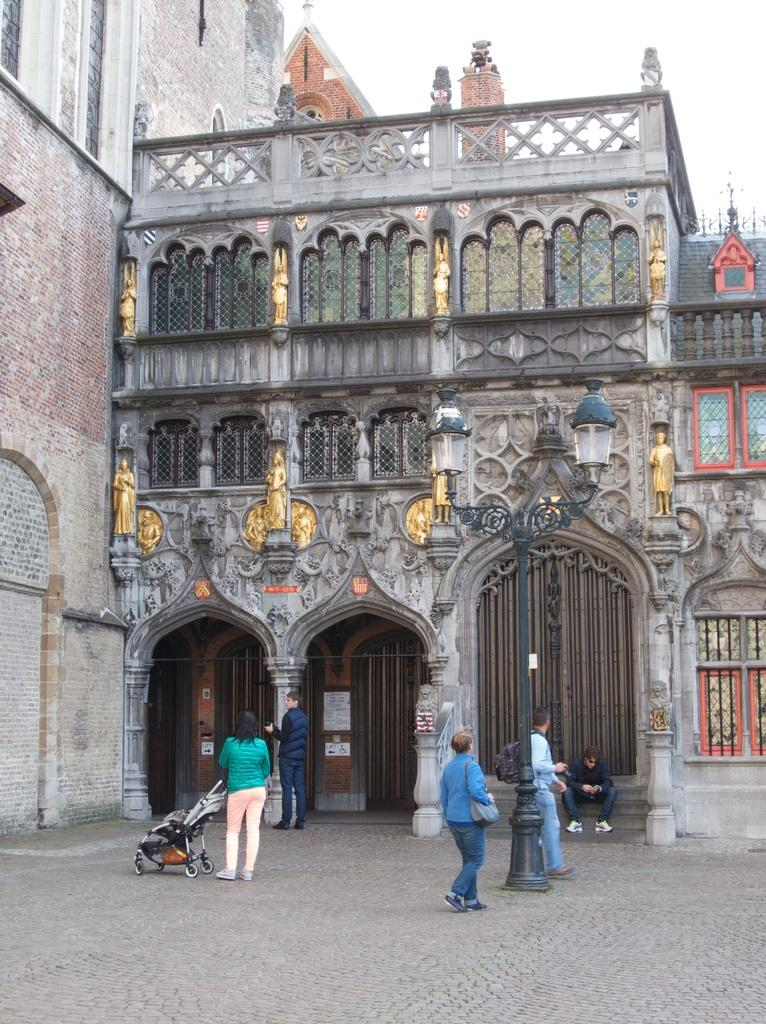Who or what can be seen in the image? There are people in the image. What can be seen in the distance behind the people? There is a building in the background of the image. What type of balloon is being used by the people in the image? There is no balloon present in the image. How many tubs are visible in the image? There are no tubs visible in the image. 